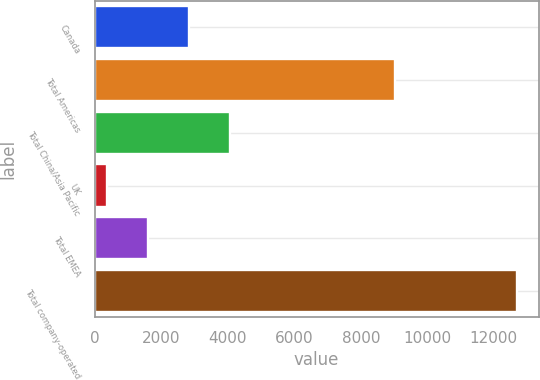Convert chart to OTSL. <chart><loc_0><loc_0><loc_500><loc_500><bar_chart><fcel>Canada<fcel>Total Americas<fcel>Total China/Asia Pacific<fcel>UK<fcel>Total EMEA<fcel>Total company-operated<nl><fcel>2835<fcel>9019<fcel>4069.5<fcel>366<fcel>1600.5<fcel>12711<nl></chart> 